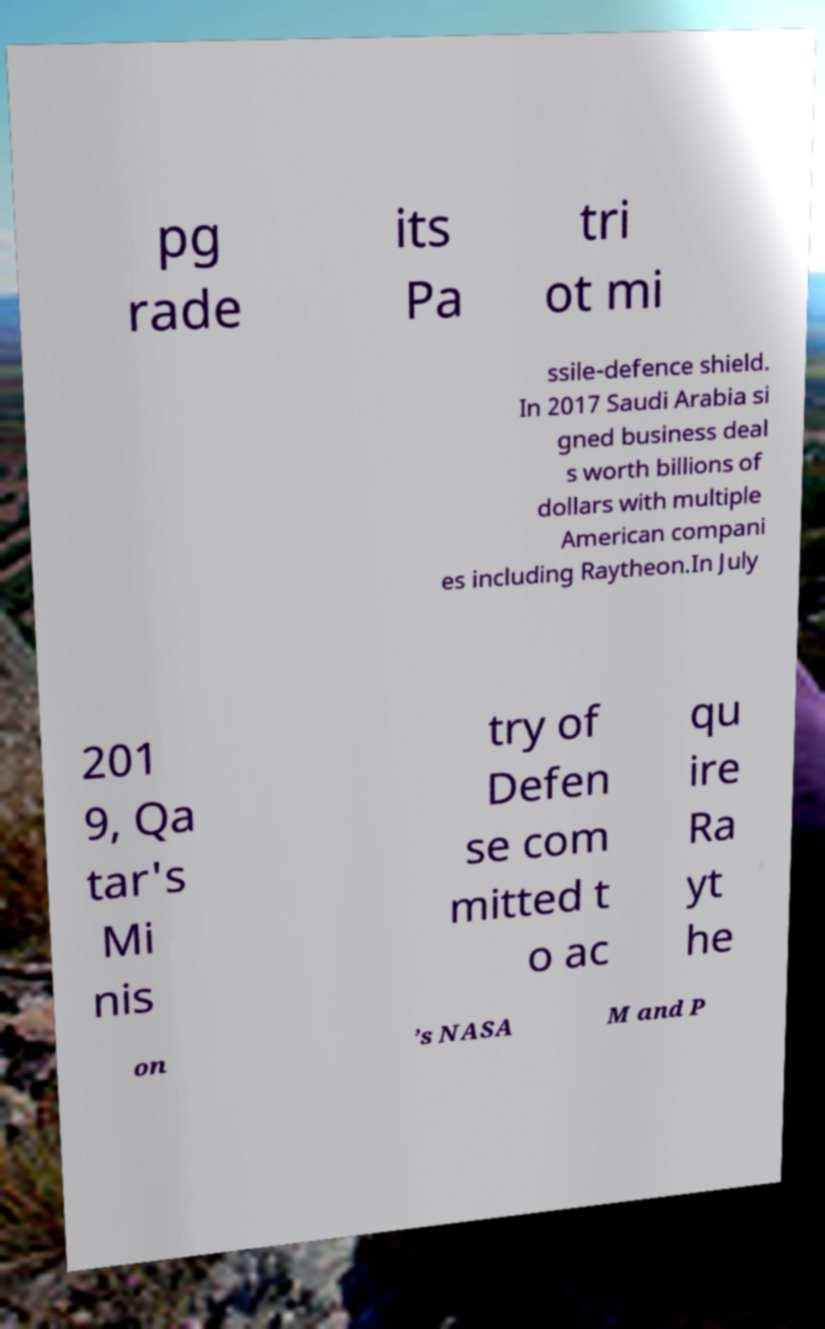Please identify and transcribe the text found in this image. pg rade its Pa tri ot mi ssile-defence shield. In 2017 Saudi Arabia si gned business deal s worth billions of dollars with multiple American compani es including Raytheon.In July 201 9, Qa tar's Mi nis try of Defen se com mitted t o ac qu ire Ra yt he on ’s NASA M and P 